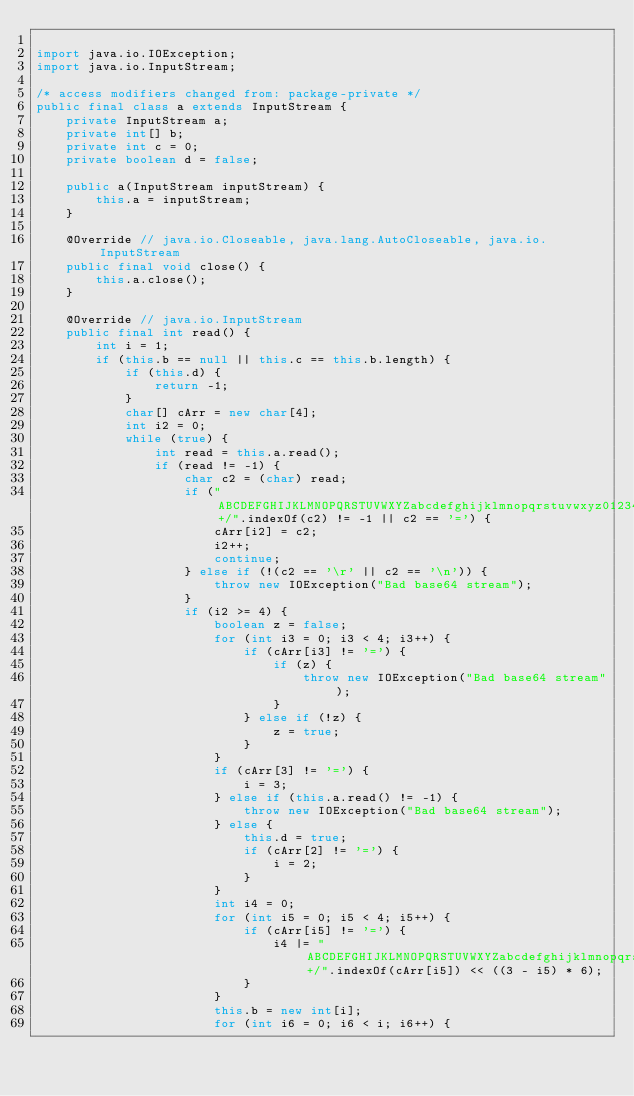<code> <loc_0><loc_0><loc_500><loc_500><_Java_>
import java.io.IOException;
import java.io.InputStream;

/* access modifiers changed from: package-private */
public final class a extends InputStream {
    private InputStream a;
    private int[] b;
    private int c = 0;
    private boolean d = false;

    public a(InputStream inputStream) {
        this.a = inputStream;
    }

    @Override // java.io.Closeable, java.lang.AutoCloseable, java.io.InputStream
    public final void close() {
        this.a.close();
    }

    @Override // java.io.InputStream
    public final int read() {
        int i = 1;
        if (this.b == null || this.c == this.b.length) {
            if (this.d) {
                return -1;
            }
            char[] cArr = new char[4];
            int i2 = 0;
            while (true) {
                int read = this.a.read();
                if (read != -1) {
                    char c2 = (char) read;
                    if ("ABCDEFGHIJKLMNOPQRSTUVWXYZabcdefghijklmnopqrstuvwxyz0123456789+/".indexOf(c2) != -1 || c2 == '=') {
                        cArr[i2] = c2;
                        i2++;
                        continue;
                    } else if (!(c2 == '\r' || c2 == '\n')) {
                        throw new IOException("Bad base64 stream");
                    }
                    if (i2 >= 4) {
                        boolean z = false;
                        for (int i3 = 0; i3 < 4; i3++) {
                            if (cArr[i3] != '=') {
                                if (z) {
                                    throw new IOException("Bad base64 stream");
                                }
                            } else if (!z) {
                                z = true;
                            }
                        }
                        if (cArr[3] != '=') {
                            i = 3;
                        } else if (this.a.read() != -1) {
                            throw new IOException("Bad base64 stream");
                        } else {
                            this.d = true;
                            if (cArr[2] != '=') {
                                i = 2;
                            }
                        }
                        int i4 = 0;
                        for (int i5 = 0; i5 < 4; i5++) {
                            if (cArr[i5] != '=') {
                                i4 |= "ABCDEFGHIJKLMNOPQRSTUVWXYZabcdefghijklmnopqrstuvwxyz0123456789+/".indexOf(cArr[i5]) << ((3 - i5) * 6);
                            }
                        }
                        this.b = new int[i];
                        for (int i6 = 0; i6 < i; i6++) {</code> 